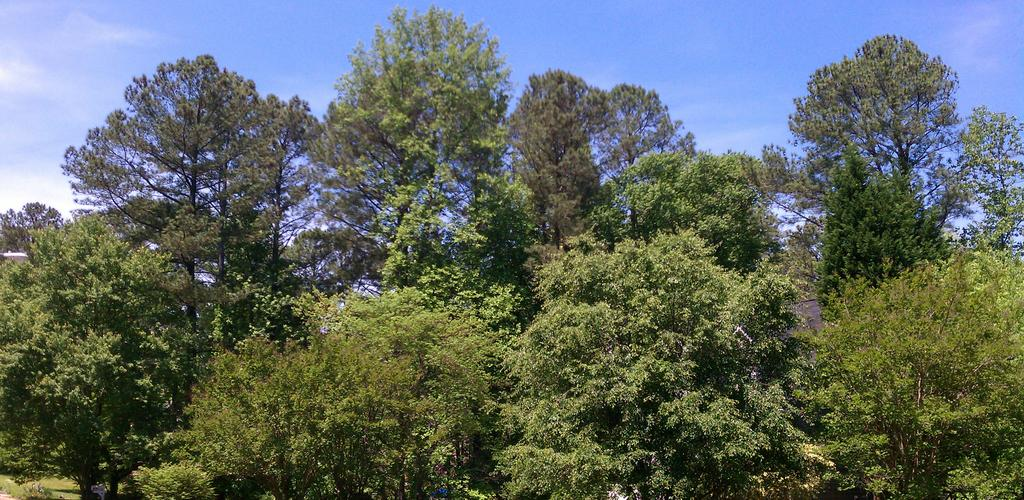What can be seen in the foreground of the image? There are trees and roofs of buildings in the foreground of the image. What is visible at the top of the image? The sky is visible at the top of the image. Can you see any wrens perched on the bananas in the image? There are no wrens or bananas present in the image. 